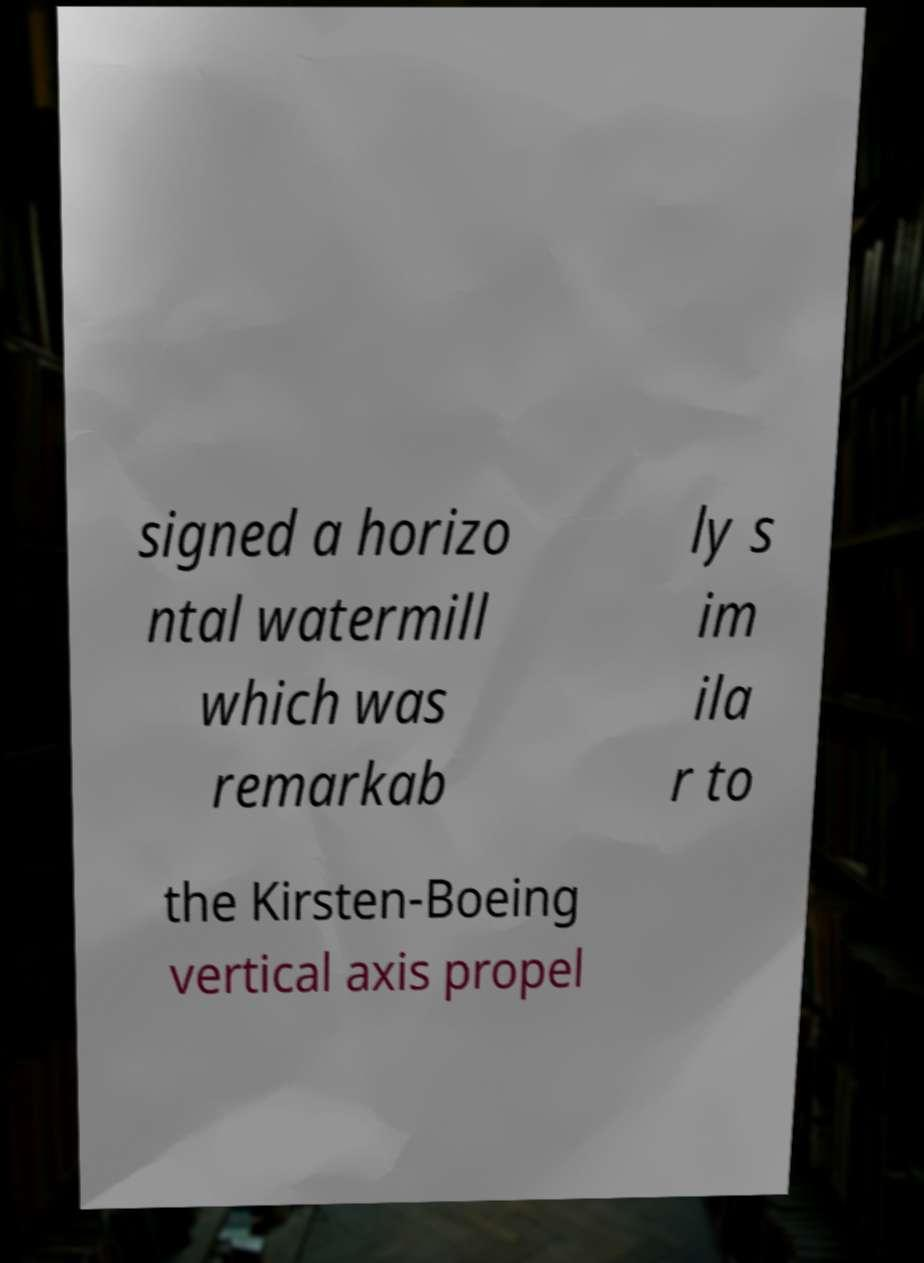Can you read and provide the text displayed in the image?This photo seems to have some interesting text. Can you extract and type it out for me? signed a horizo ntal watermill which was remarkab ly s im ila r to the Kirsten-Boeing vertical axis propel 